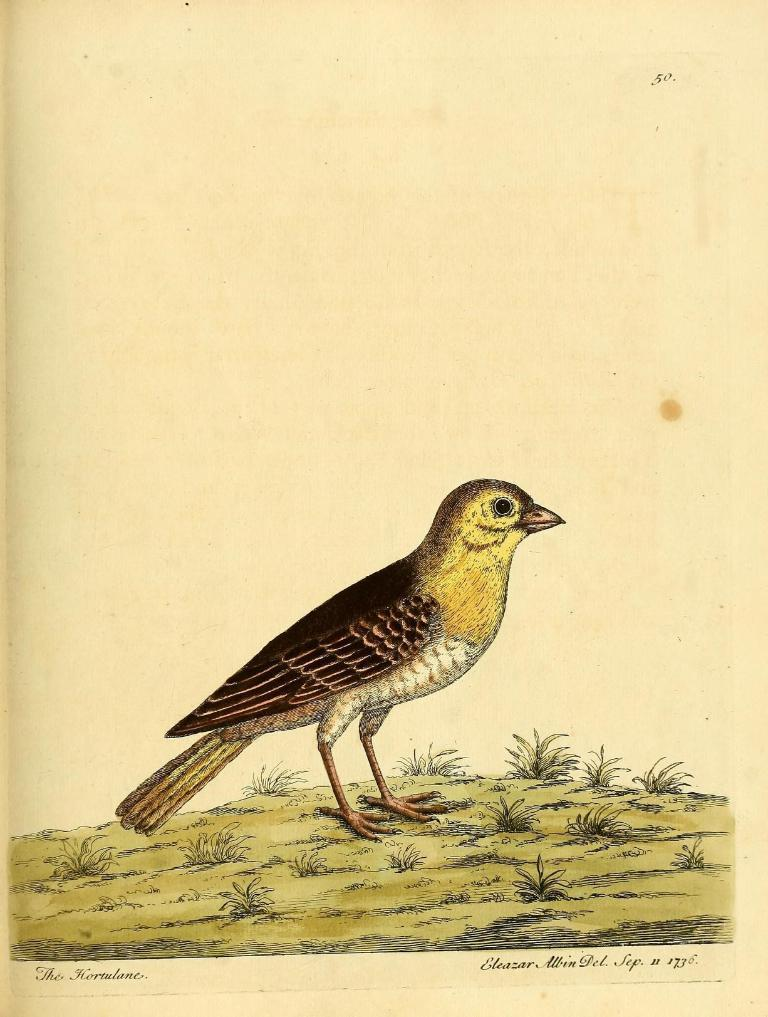What is depicted in the drawing in the image? There is a drawing of a bird in the image. What colors are used to create the bird in the drawing? The bird is maroon, yellow, and white in color. What type of surface can be seen in the image? There is ground visible in the image. What type of vegetation is present on the ground? There is grass on the ground. What else can be found in the image besides the drawing of the bird? There are words written in the image. How many cherries are hanging from the bird's beak in the image? There are no cherries present in the image, and the bird's beak is not depicted as holding any cherries. 